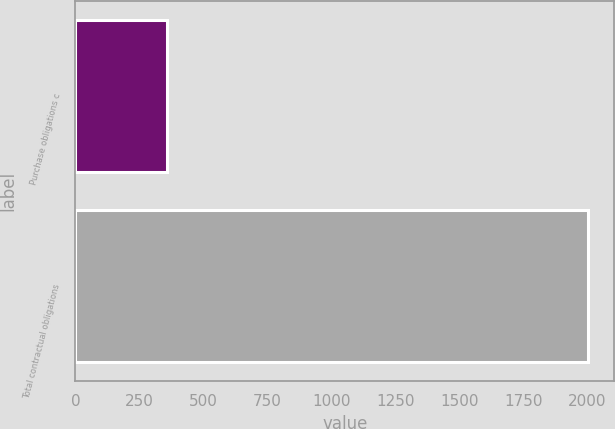Convert chart to OTSL. <chart><loc_0><loc_0><loc_500><loc_500><bar_chart><fcel>Purchase obligations c<fcel>Total contractual obligations<nl><fcel>357<fcel>2005<nl></chart> 